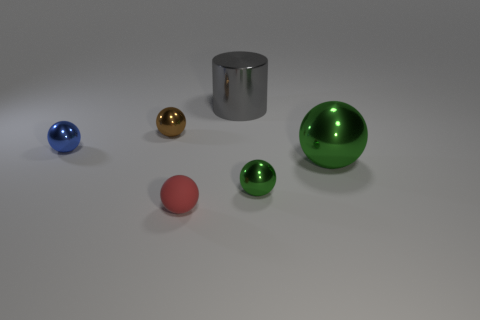Subtract all rubber balls. How many balls are left? 4 Subtract all green spheres. How many spheres are left? 3 Subtract 0 blue cylinders. How many objects are left? 6 Subtract all spheres. How many objects are left? 1 Subtract 2 spheres. How many spheres are left? 3 Subtract all red spheres. Subtract all red cylinders. How many spheres are left? 4 Subtract all green cubes. How many gray spheres are left? 0 Subtract all tiny brown metal things. Subtract all small brown objects. How many objects are left? 4 Add 5 tiny rubber things. How many tiny rubber things are left? 6 Add 6 large purple matte spheres. How many large purple matte spheres exist? 6 